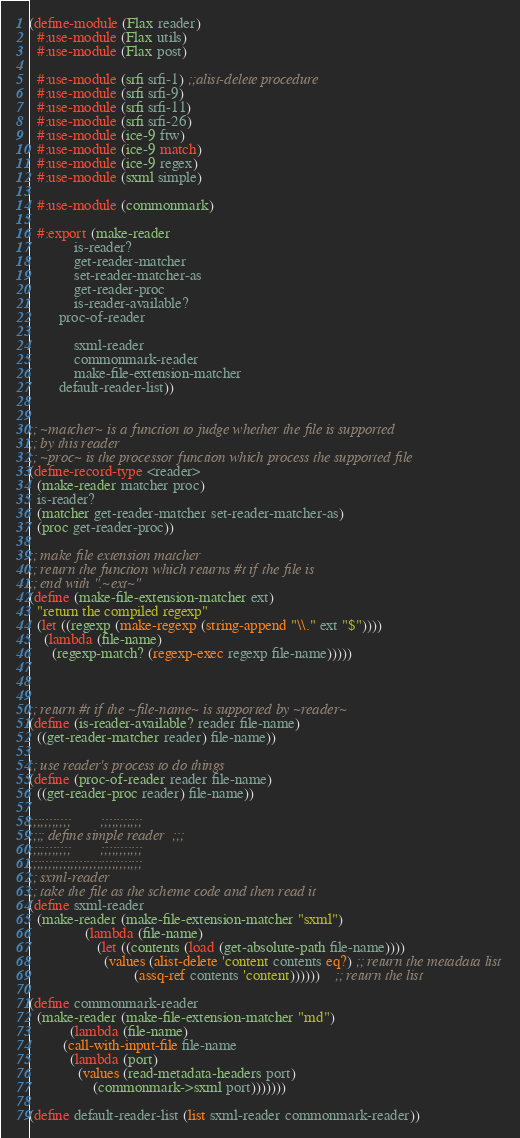Convert code to text. <code><loc_0><loc_0><loc_500><loc_500><_Scheme_>(define-module (Flax reader)
  #:use-module (Flax utils)
  #:use-module (Flax post)
  
  #:use-module (srfi srfi-1) ;;alist-delete procedure
  #:use-module (srfi srfi-9)
  #:use-module (srfi srfi-11)
  #:use-module (srfi srfi-26)
  #:use-module (ice-9 ftw)
  #:use-module (ice-9 match)
  #:use-module (ice-9 regex)
  #:use-module (sxml simple)
  
  #:use-module (commonmark)

  #:export (make-reader
            is-reader?
            get-reader-matcher
            set-reader-matcher-as
            get-reader-proc
            is-reader-available?
	    proc-of-reader
	    
            sxml-reader
            commonmark-reader
            make-file-extension-matcher
	    default-reader-list))


;; ~matcher~ is a function to judge whether the file is supported
;; by this reader
;; ~proc~ is the processor function which process the supported file
(define-record-type <reader>
  (make-reader matcher proc)
  is-reader?
  (matcher get-reader-matcher set-reader-matcher-as)
  (proc get-reader-proc))

;; make file extension matcher
;; return the function which returns #t if the file is
;; end with ".~ext~"
(define (make-file-extension-matcher ext)
  "return the compiled regexp"
  (let ((regexp (make-regexp (string-append "\\." ext "$"))))
    (lambda (file-name)
      (regexp-match? (regexp-exec regexp file-name)))))



;; return #t if the ~file-name~ is supported by ~reader~
(define (is-reader-available? reader file-name)
  ((get-reader-matcher reader) file-name))

;; use reader's process to do things
(define (proc-of-reader reader file-name)
  ((get-reader-proc reader) file-name))

;;;;;;;;;;;        ;;;;;;;;;;;
;;;; define simple reader  ;;;
;;;;;;;;;;;        ;;;;;;;;;;;
;;;;;;;;;;;;;;;;;;;;;;;;;;;;;;
;; sxml-reader
;; take the file as the scheme code and then read it
(define sxml-reader
  (make-reader (make-file-extension-matcher "sxml")
               (lambda (file-name)
                  (let ((contents (load (get-absolute-path file-name))))
                    (values (alist-delete 'content contents eq?) ;; return the metadata list
                            (assq-ref contents 'content))))))    ;; return the list

(define commonmark-reader
  (make-reader (make-file-extension-matcher "md")
	       (lambda (file-name)
		 (call-with-input-file file-name
		   (lambda (port)
		     (values (read-metadata-headers port)
			     (commonmark->sxml port)))))))

(define default-reader-list (list sxml-reader commonmark-reader))
</code> 